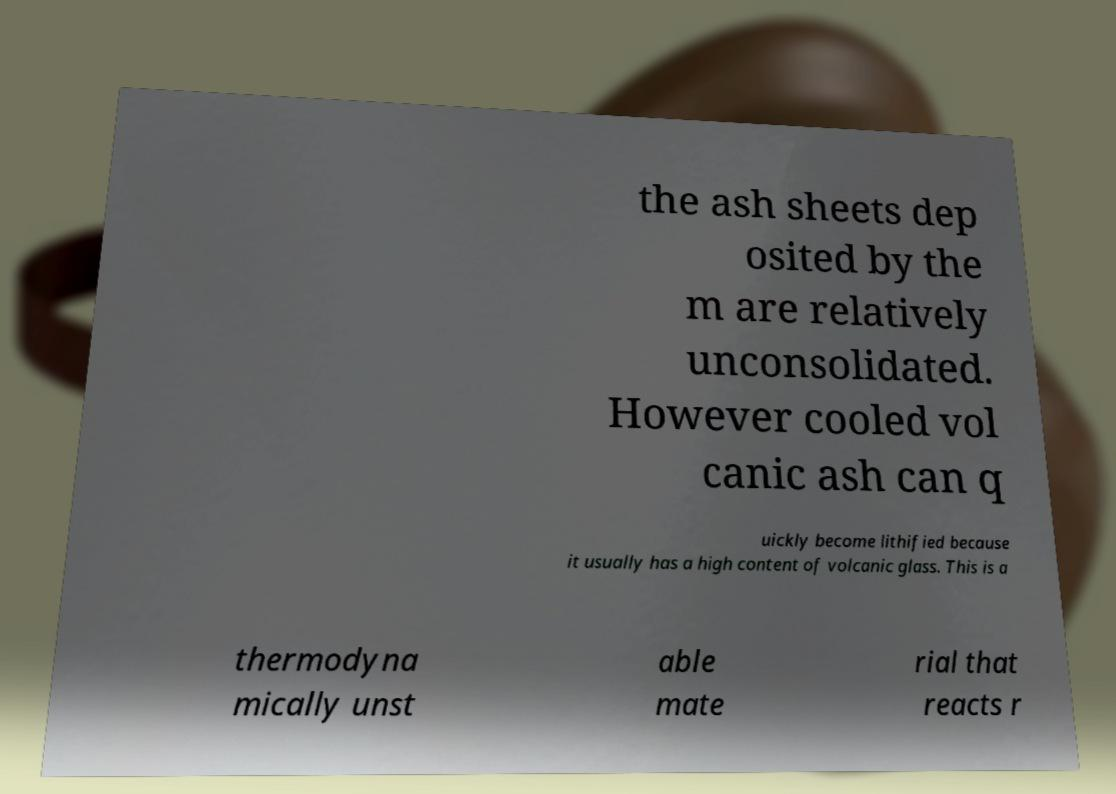For documentation purposes, I need the text within this image transcribed. Could you provide that? the ash sheets dep osited by the m are relatively unconsolidated. However cooled vol canic ash can q uickly become lithified because it usually has a high content of volcanic glass. This is a thermodyna mically unst able mate rial that reacts r 